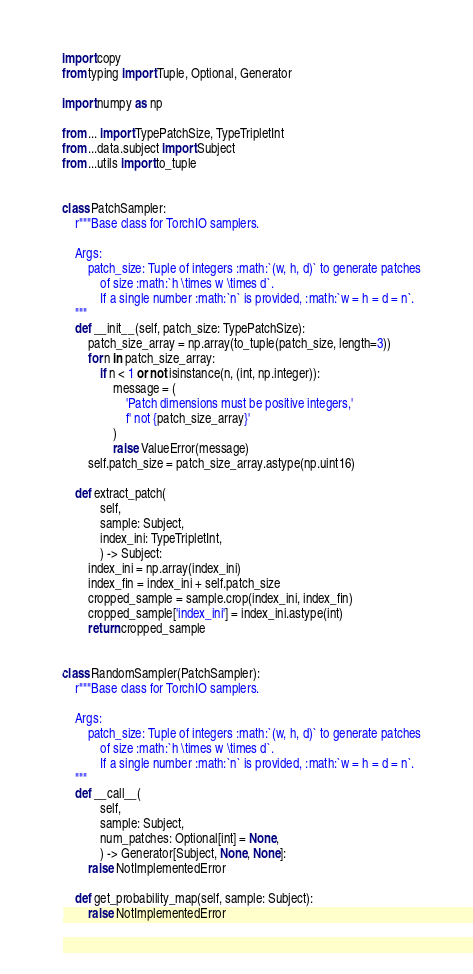Convert code to text. <code><loc_0><loc_0><loc_500><loc_500><_Python_>import copy
from typing import Tuple, Optional, Generator

import numpy as np

from ... import TypePatchSize, TypeTripletInt
from ...data.subject import Subject
from ...utils import to_tuple


class PatchSampler:
    r"""Base class for TorchIO samplers.

    Args:
        patch_size: Tuple of integers :math:`(w, h, d)` to generate patches
            of size :math:`h \times w \times d`.
            If a single number :math:`n` is provided, :math:`w = h = d = n`.
    """
    def __init__(self, patch_size: TypePatchSize):
        patch_size_array = np.array(to_tuple(patch_size, length=3))
        for n in patch_size_array:
            if n < 1 or not isinstance(n, (int, np.integer)):
                message = (
                    'Patch dimensions must be positive integers,'
                    f' not {patch_size_array}'
                )
                raise ValueError(message)
        self.patch_size = patch_size_array.astype(np.uint16)

    def extract_patch(
            self,
            sample: Subject,
            index_ini: TypeTripletInt,
            ) -> Subject:
        index_ini = np.array(index_ini)
        index_fin = index_ini + self.patch_size
        cropped_sample = sample.crop(index_ini, index_fin)
        cropped_sample['index_ini'] = index_ini.astype(int)
        return cropped_sample


class RandomSampler(PatchSampler):
    r"""Base class for TorchIO samplers.

    Args:
        patch_size: Tuple of integers :math:`(w, h, d)` to generate patches
            of size :math:`h \times w \times d`.
            If a single number :math:`n` is provided, :math:`w = h = d = n`.
    """
    def __call__(
            self,
            sample: Subject,
            num_patches: Optional[int] = None,
            ) -> Generator[Subject, None, None]:
        raise NotImplementedError

    def get_probability_map(self, sample: Subject):
        raise NotImplementedError
</code> 